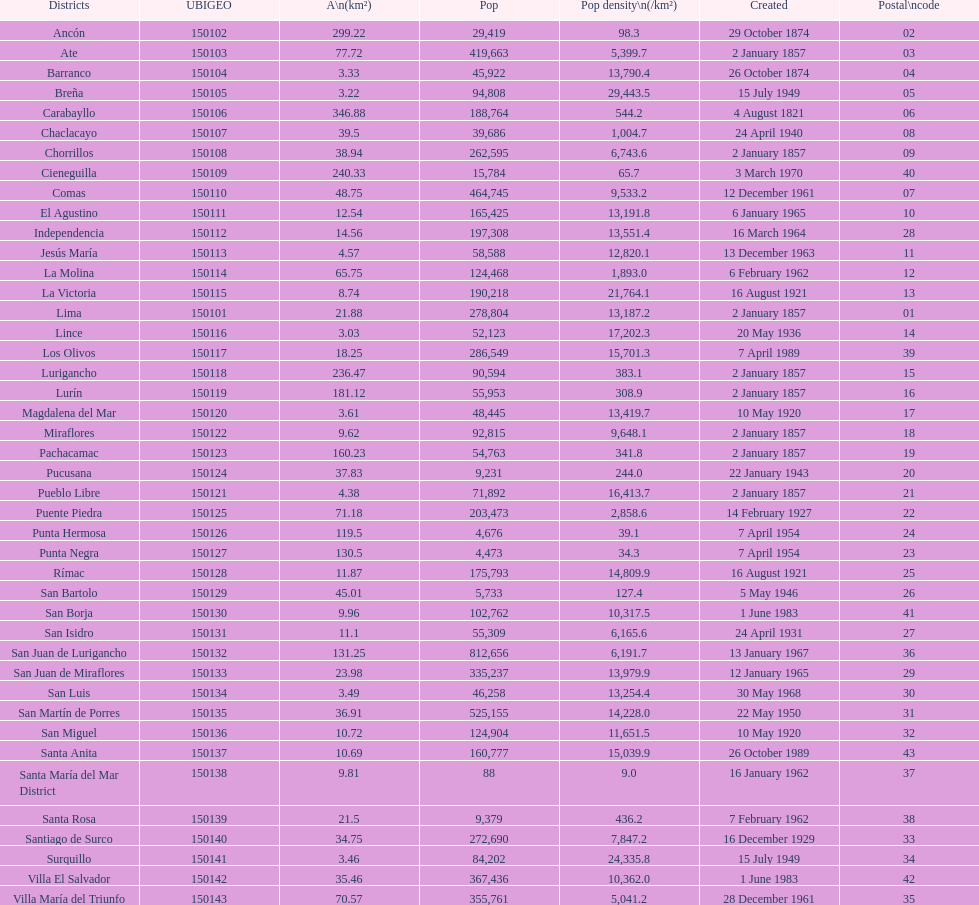What district has the least amount of population? Santa María del Mar District. 